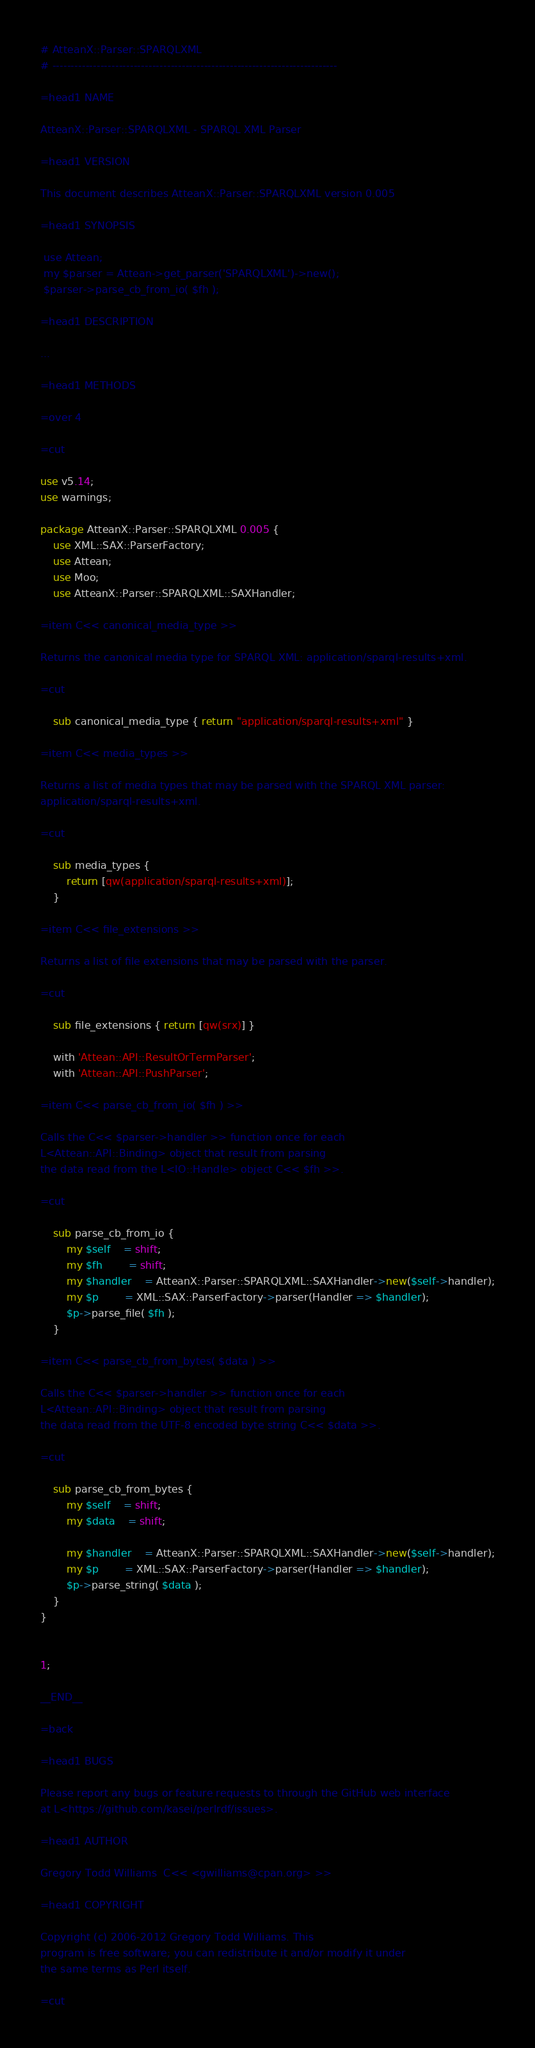Convert code to text. <code><loc_0><loc_0><loc_500><loc_500><_Perl_># AtteanX::Parser::SPARQLXML
# -----------------------------------------------------------------------------

=head1 NAME

AtteanX::Parser::SPARQLXML - SPARQL XML Parser

=head1 VERSION

This document describes AtteanX::Parser::SPARQLXML version 0.005

=head1 SYNOPSIS

 use Attean;
 my $parser = Attean->get_parser('SPARQLXML')->new();
 $parser->parse_cb_from_io( $fh );

=head1 DESCRIPTION

...

=head1 METHODS

=over 4

=cut

use v5.14;
use warnings;

package AtteanX::Parser::SPARQLXML 0.005 {
	use XML::SAX::ParserFactory;
	use Attean;
	use Moo;
	use AtteanX::Parser::SPARQLXML::SAXHandler;
	
=item C<< canonical_media_type >>

Returns the canonical media type for SPARQL XML: application/sparql-results+xml.

=cut

	sub canonical_media_type { return "application/sparql-results+xml" }

=item C<< media_types >>

Returns a list of media types that may be parsed with the SPARQL XML parser:
application/sparql-results+xml.

=cut

	sub media_types {
		return [qw(application/sparql-results+xml)];
	}
	
=item C<< file_extensions >>

Returns a list of file extensions that may be parsed with the parser.

=cut

	sub file_extensions { return [qw(srx)] }

	with 'Attean::API::ResultOrTermParser';
	with 'Attean::API::PushParser';

=item C<< parse_cb_from_io( $fh ) >>

Calls the C<< $parser->handler >> function once for each
L<Attean::API::Binding> object that result from parsing
the data read from the L<IO::Handle> object C<< $fh >>.

=cut

	sub parse_cb_from_io {
		my $self	= shift;
		my $fh		= shift;
		my $handler	= AtteanX::Parser::SPARQLXML::SAXHandler->new($self->handler);
		my $p		= XML::SAX::ParserFactory->parser(Handler => $handler);
		$p->parse_file( $fh );
	}

=item C<< parse_cb_from_bytes( $data ) >>

Calls the C<< $parser->handler >> function once for each
L<Attean::API::Binding> object that result from parsing
the data read from the UTF-8 encoded byte string C<< $data >>.

=cut

	sub parse_cb_from_bytes {
		my $self	= shift;
		my $data	= shift;
	
		my $handler	= AtteanX::Parser::SPARQLXML::SAXHandler->new($self->handler);
		my $p		= XML::SAX::ParserFactory->parser(Handler => $handler);
		$p->parse_string( $data );
	}
}


1;

__END__

=back

=head1 BUGS

Please report any bugs or feature requests to through the GitHub web interface
at L<https://github.com/kasei/perlrdf/issues>.

=head1 AUTHOR

Gregory Todd Williams  C<< <gwilliams@cpan.org> >>

=head1 COPYRIGHT

Copyright (c) 2006-2012 Gregory Todd Williams. This
program is free software; you can redistribute it and/or modify it under
the same terms as Perl itself.

=cut
</code> 